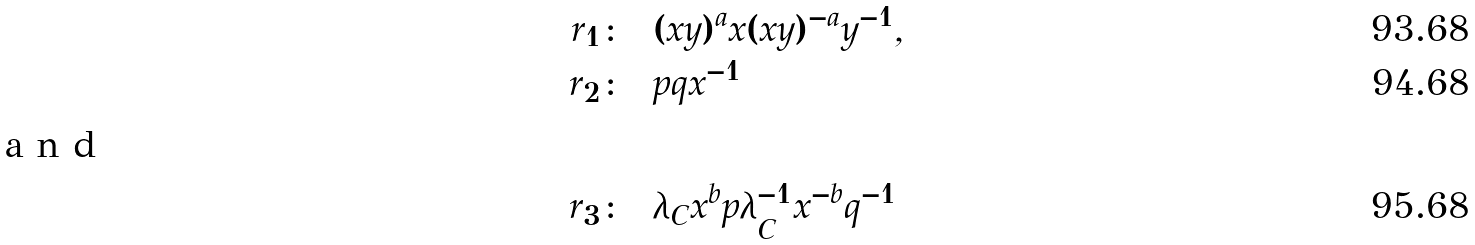<formula> <loc_0><loc_0><loc_500><loc_500>r _ { 1 } & \colon = ( x y ) ^ { a } x ( x y ) ^ { - a } y ^ { - 1 } , \\ r _ { 2 } & \colon = p q x ^ { - 1 } \\ \intertext { a n d } r _ { 3 } & \colon = \lambda _ { C } x ^ { b } p \lambda ^ { - 1 } _ { C } x ^ { - b } q ^ { - 1 }</formula> 